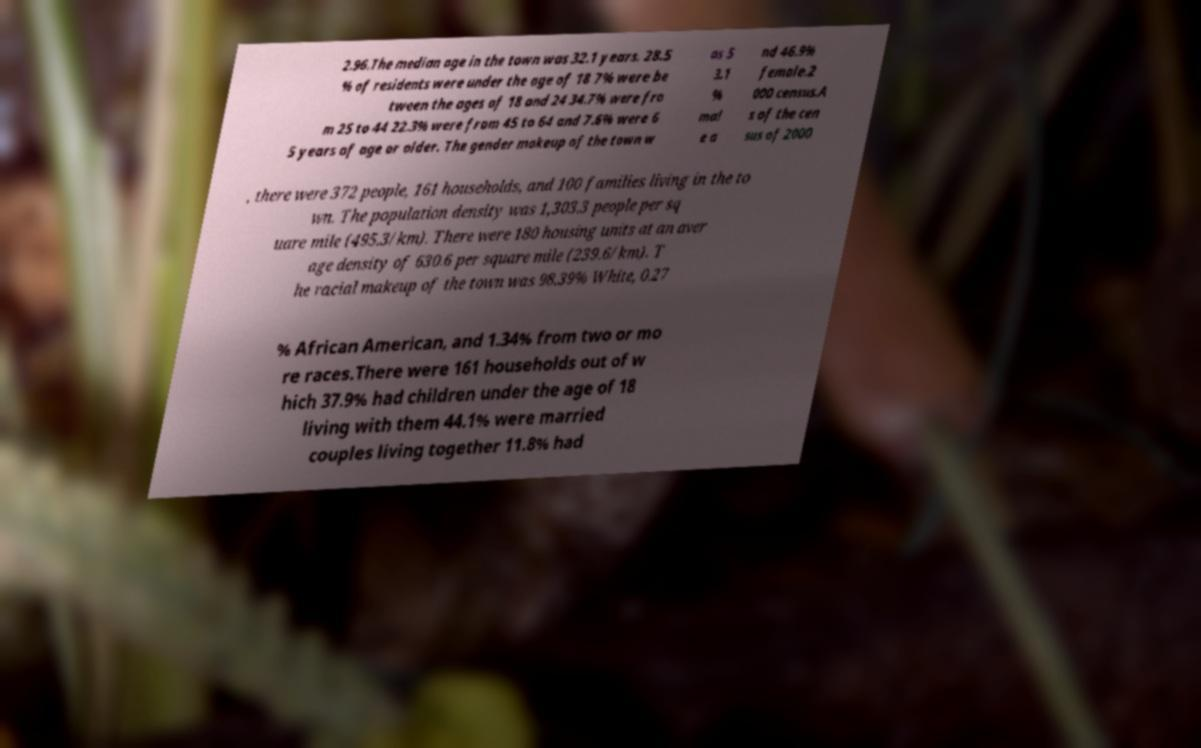Please read and relay the text visible in this image. What does it say? 2.96.The median age in the town was 32.1 years. 28.5 % of residents were under the age of 18 7% were be tween the ages of 18 and 24 34.7% were fro m 25 to 44 22.3% were from 45 to 64 and 7.6% were 6 5 years of age or older. The gender makeup of the town w as 5 3.1 % mal e a nd 46.9% female.2 000 census.A s of the cen sus of 2000 , there were 372 people, 161 households, and 100 families living in the to wn. The population density was 1,303.3 people per sq uare mile (495.3/km). There were 180 housing units at an aver age density of 630.6 per square mile (239.6/km). T he racial makeup of the town was 98.39% White, 0.27 % African American, and 1.34% from two or mo re races.There were 161 households out of w hich 37.9% had children under the age of 18 living with them 44.1% were married couples living together 11.8% had 